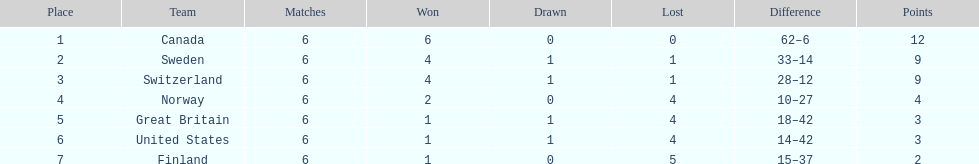In the 1951 world ice hockey championships, how many teams secured a minimum of two victories? 4. 